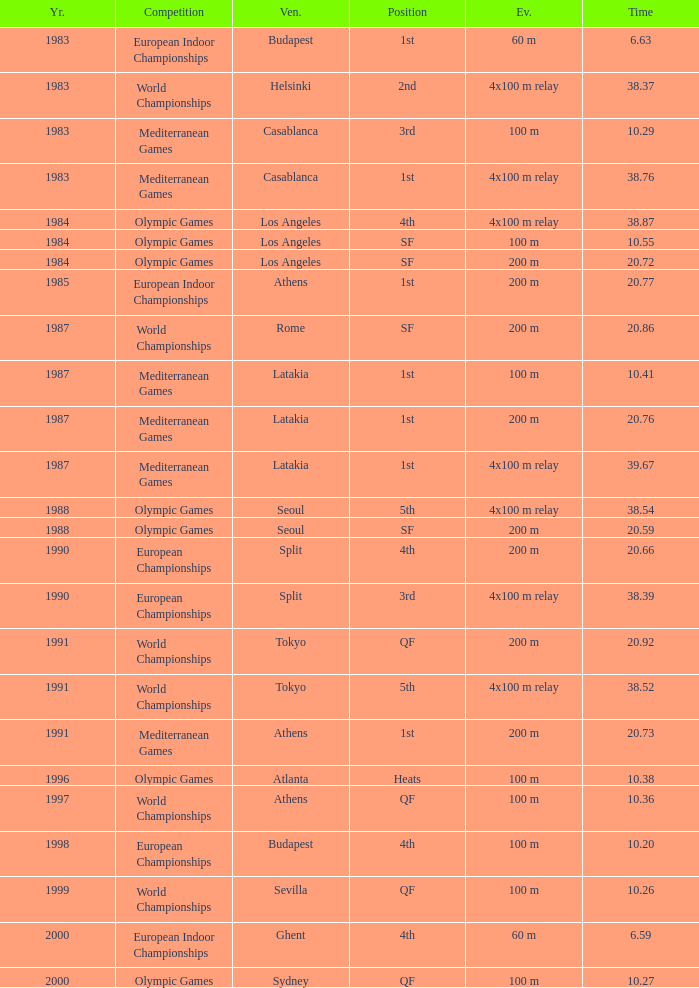What Event has a Position of 1st, a Year of 1983, and a Venue of budapest? 60 m. 